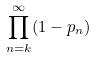<formula> <loc_0><loc_0><loc_500><loc_500>\prod _ { n = k } ^ { \infty } ( 1 - p _ { n } )</formula> 